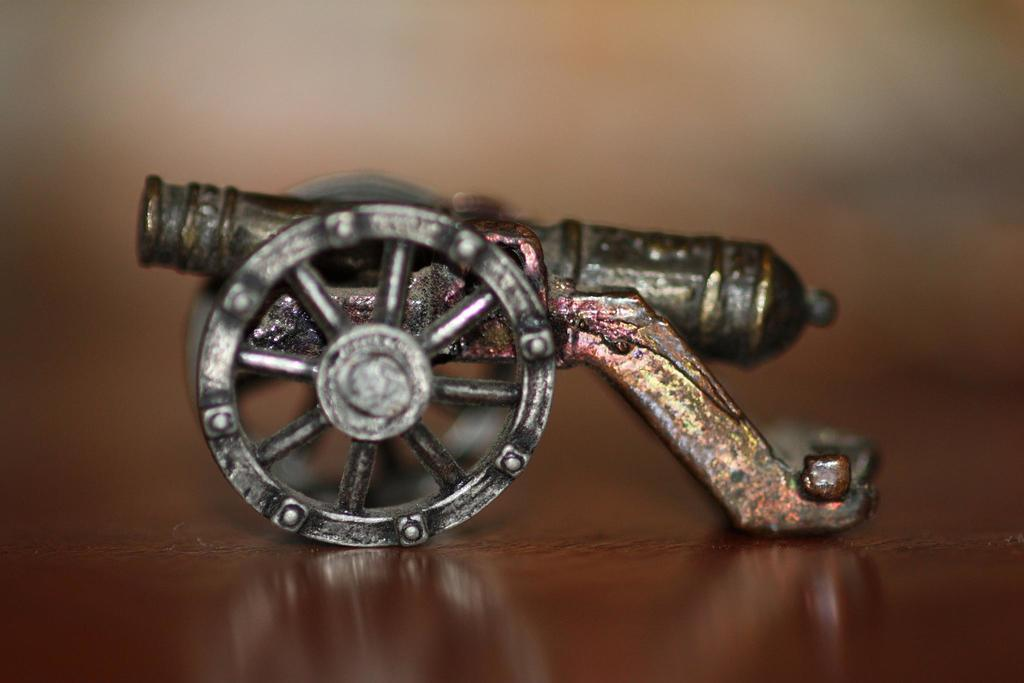What type of object is the main subject of the image? There is a metallic structure of a war weapon in the image. How is the war weapon positioned in the image? The war weapon is on a cart. Where is the cart with the war weapon located? The cart is placed on a table. What type of neck accessory is being discussed by the committee in the image? There is no committee or neck accessory present in the image; it features a metallic structure of a war weapon on a cart placed on a table. 